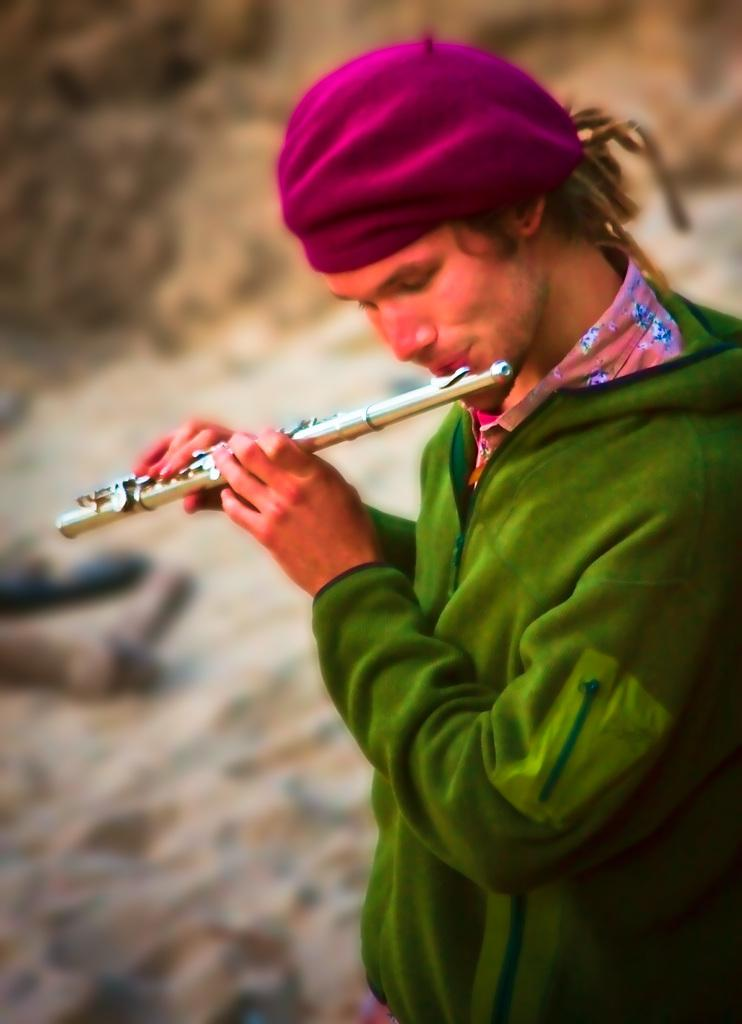Who is the main subject in the image? There is a man in the image. What is the man wearing? The man is wearing a green dress. What is the man holding in the image? The man is holding a flute near his mouth near his mouth. Can you describe the background of the image? The background of the image is blurred. How many legs does the man have in the image? The man has two legs, but this information is not explicitly mentioned in the facts provided. However, it is a reasonable assumption to make based on the general appearance of a human being. 